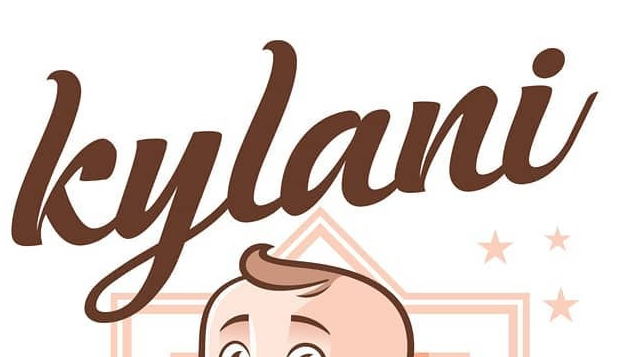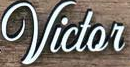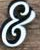What text appears in these images from left to right, separated by a semicolon? kylani; Victor; & 